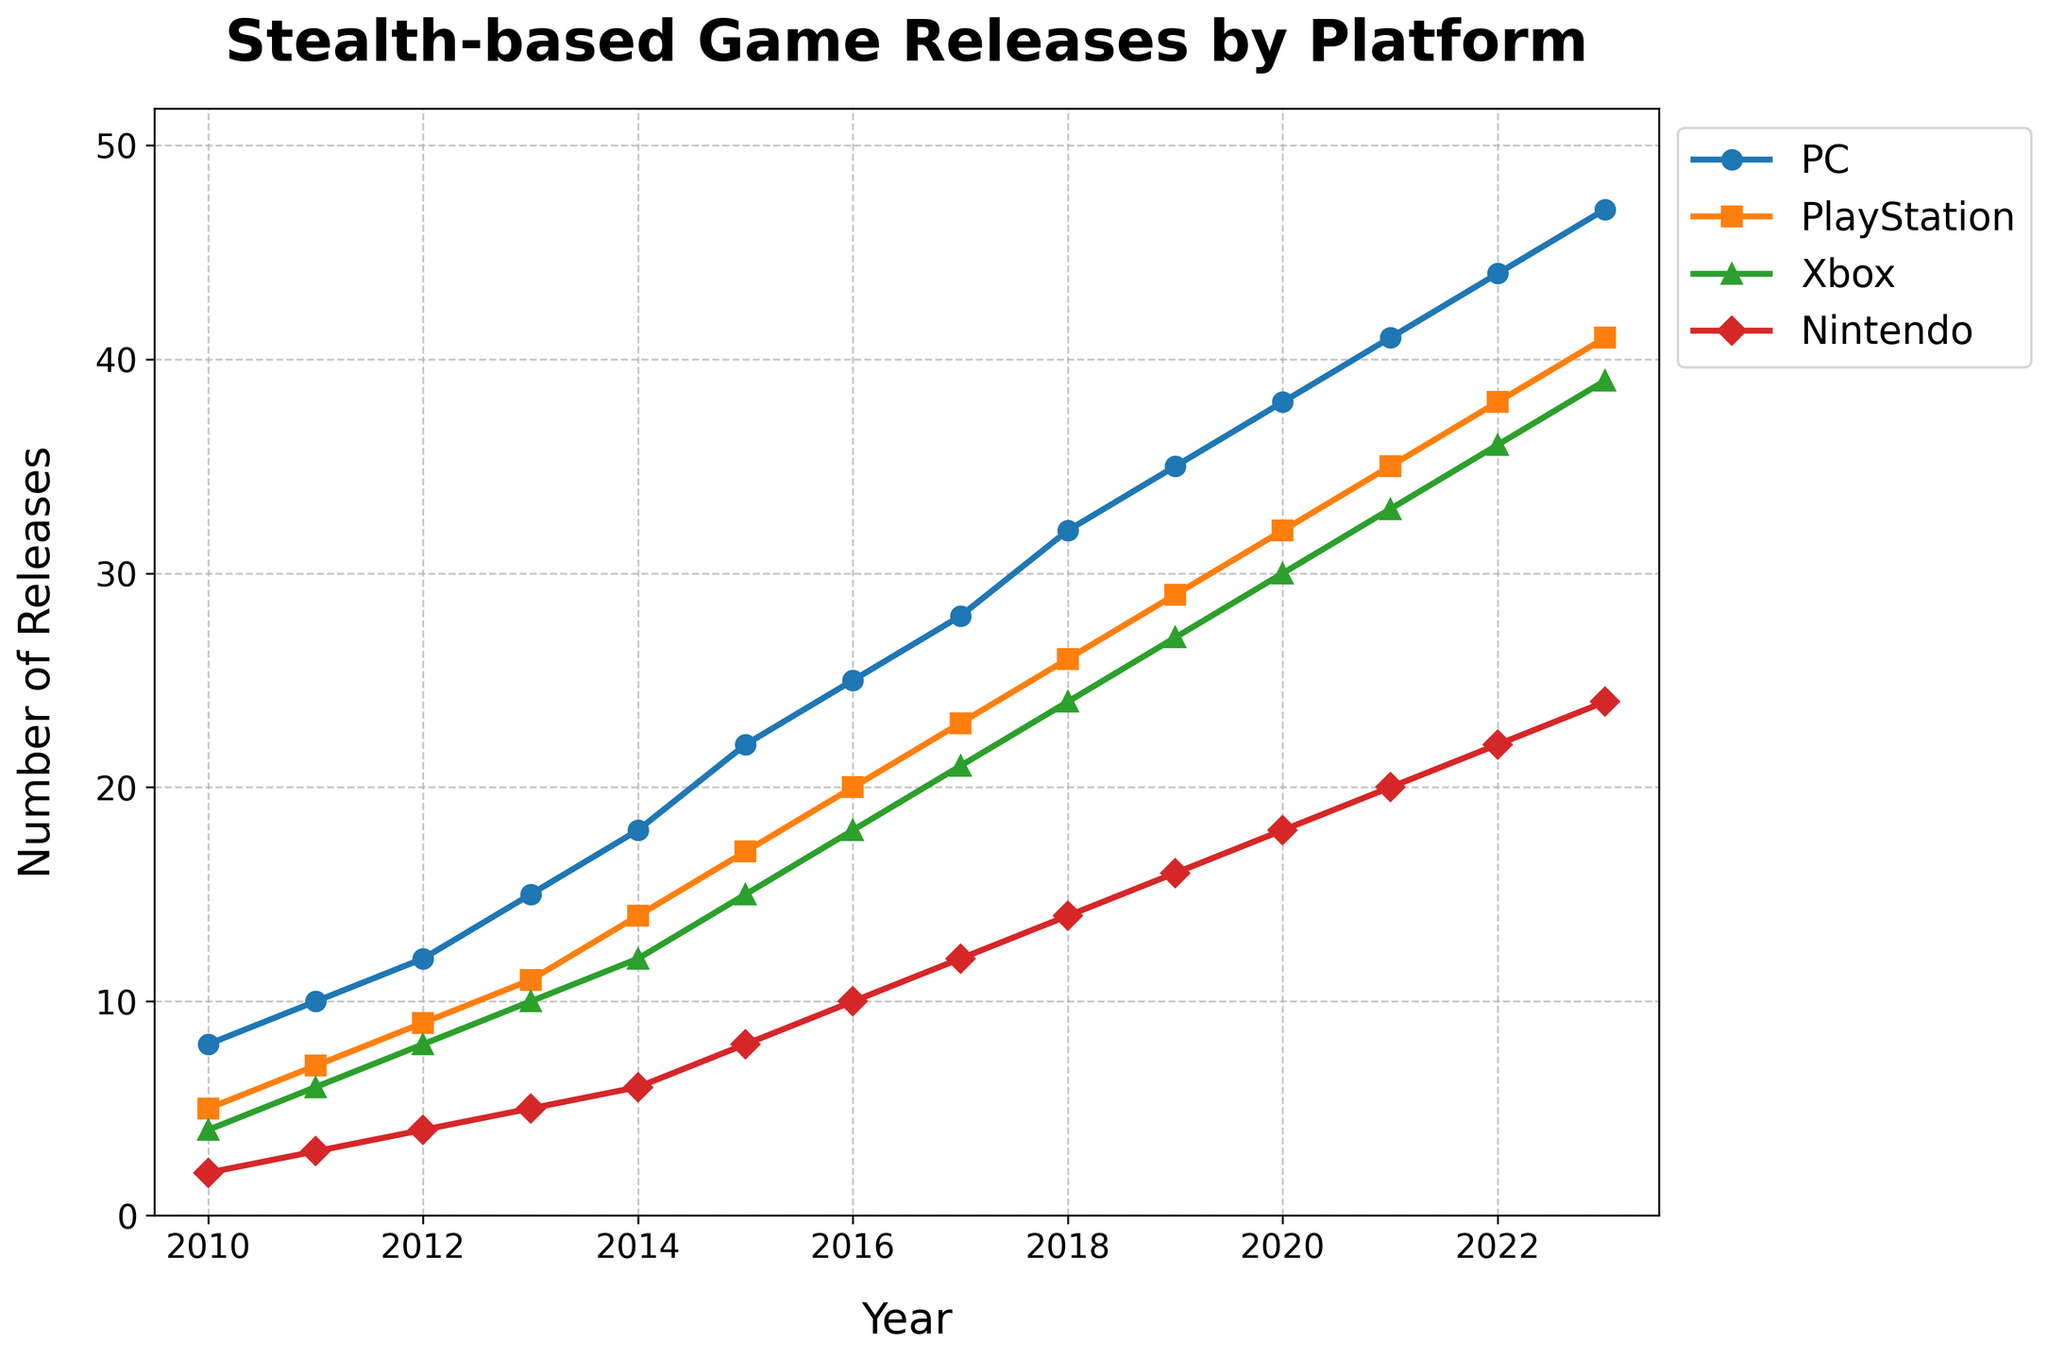Which platform had the highest number of stealth-based game releases in 2023? The line for the year 2023, look for the highest point among all platforms. PC stands higher than PlayStation, Xbox, and Nintendo.
Answer: PC How many stealth-based games were released on Nintendo between 2010 and 2013? Add the values for Nintendo from 2010 to 2013: 2 (2010) + 3 (2011) + 4 (2012) + 5 (2013) = 14.
Answer: 14 In which year did PC surpass 30 stealth-based game releases? Observe the PC line and find the year where the value crosses 30. This happens between 2018 (32 releases).
Answer: 2018 What is the difference in the number of releases between PlayStation and Xbox in 2015? Find the values for PlayStation and Xbox in 2015: PlayStation (17) - Xbox (15) = 2.
Answer: 2 Which platform had the smallest growth in releases from 2010 to 2023? Comparing the values in 2010 to those in 2023 for each platform, Nintendo shows the least increase: 24 - 2 = 22.
Answer: Nintendo What is the total number of game releases across all platforms in 2016? Add the values for PC, PlayStation, Xbox, and Nintendo in 2016: 25 + 20 + 18 + 10 = 73.
Answer: 73 When did Xbox start releasing more games than Nintendo? Compare Xbox and Nintendo yearly until Xbox has a higher release, which happens at 2012: Xbox (8), Nintendo (4).
Answer: 2012 Which two platforms had the most similar number of releases in 2021? Compare the values of each platform in 2021 and find the pair with the closest values: PlayStation (35) and Xbox (33). The difference is 2.
Answer: PlayStation and Xbox Between which consecutive years did PC see the largest increase in game releases? Look at the yearly increases for PC and find the largest one: 2013 to 2014 (15 to 18) is an increase of 3. The largest increase actually is from 2016 (25) to 2017 (28), which is an increase of 3.
Answer: 2016-2017 How many more stealth-based games did PlayStation release in 2023 compared to 2010? Subtract the number of releases in 2010 from those in 2023 for PlayStation: 41 - 5 = 36.
Answer: 36 